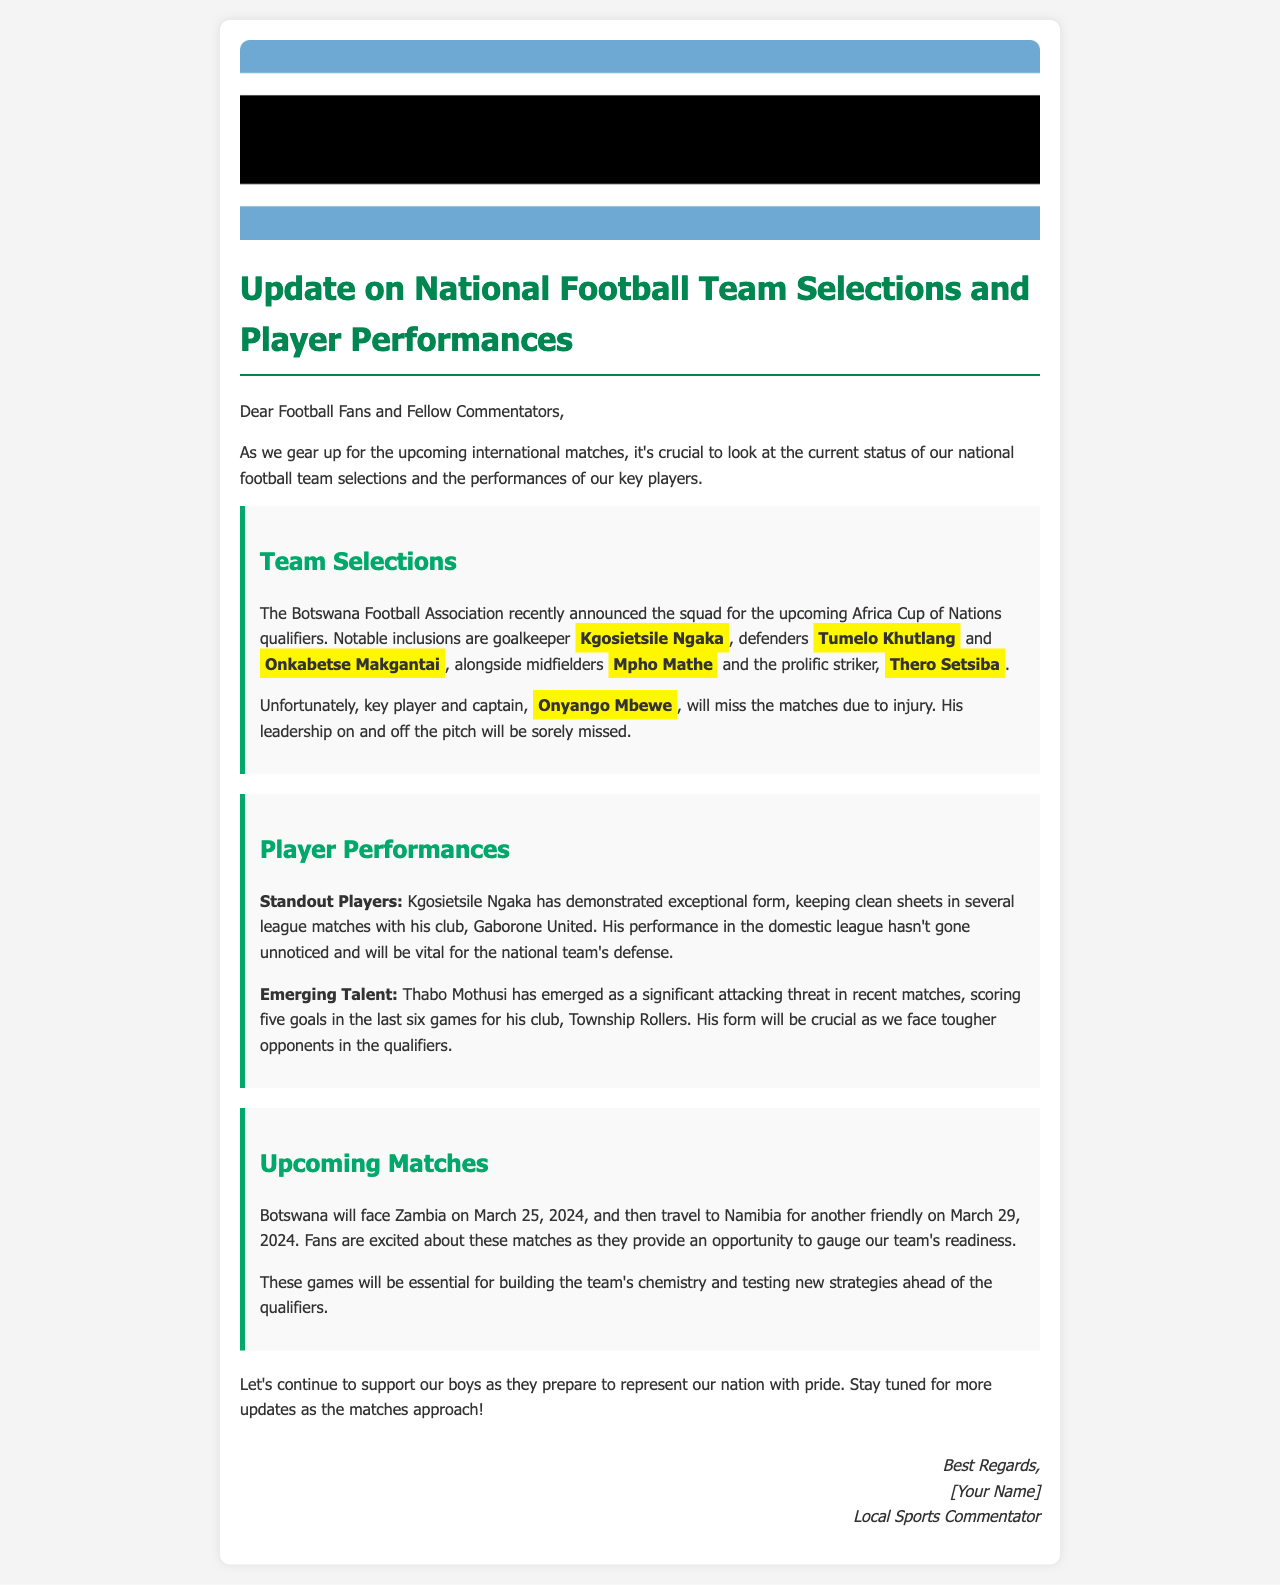What is the title of the document? The title of the document is presented prominently at the top, stating the main subject of the update.
Answer: Update on National Football Team Selections and Player Performances Who is the notable goalkeeper included in the squad? The document mentions a specific goalkeeper as a notable inclusion in the team selection.
Answer: Kgosietsile Ngaka Which player is missing the matches due to injury? The document specifies a key player that will miss the upcoming matches and provides their name.
Answer: Onyango Mbewe What will be the date of the match against Zambia? The document lists the upcoming match dates, including the specific date for the game against Zambia.
Answer: March 25, 2024 How many goals has Thabo Mothusi scored in his last six games? The document highlights the performance of Thabo Mothusi, providing his goal tally in a specific timeframe.
Answer: Five goals What is the purpose of the upcoming matches against Zambia and Namibia? The document discusses the importance of these matches for the team's development and preparation.
Answer: Building the team's chemistry and testing new strategies Who is the author of the document? The document concludes with a signature that identifies the writer.
Answer: Local Sports Commentator 